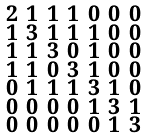Convert formula to latex. <formula><loc_0><loc_0><loc_500><loc_500>\begin{smallmatrix} 2 & 1 & 1 & 1 & 0 & 0 & 0 \\ 1 & 3 & 1 & 1 & 1 & 0 & 0 \\ 1 & 1 & 3 & 0 & 1 & 0 & 0 \\ 1 & 1 & 0 & 3 & 1 & 0 & 0 \\ 0 & 1 & 1 & 1 & 3 & 1 & 0 \\ 0 & 0 & 0 & 0 & 1 & 3 & 1 \\ 0 & 0 & 0 & 0 & 0 & 1 & 3 \end{smallmatrix}</formula> 